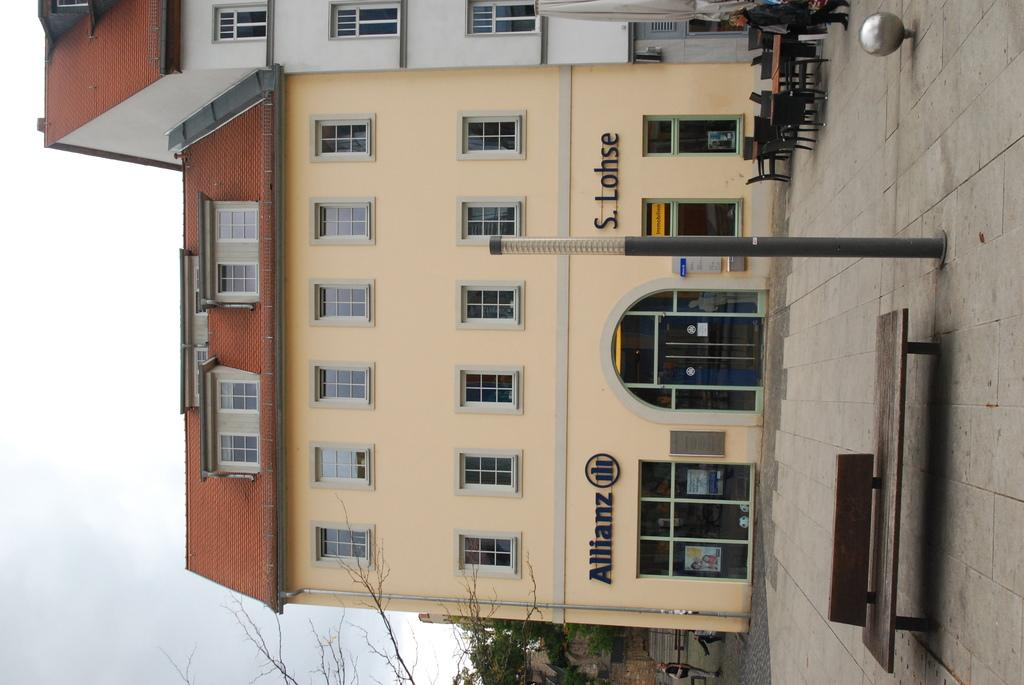<image>
Give a short and clear explanation of the subsequent image. The Allianz company is located in this building. 